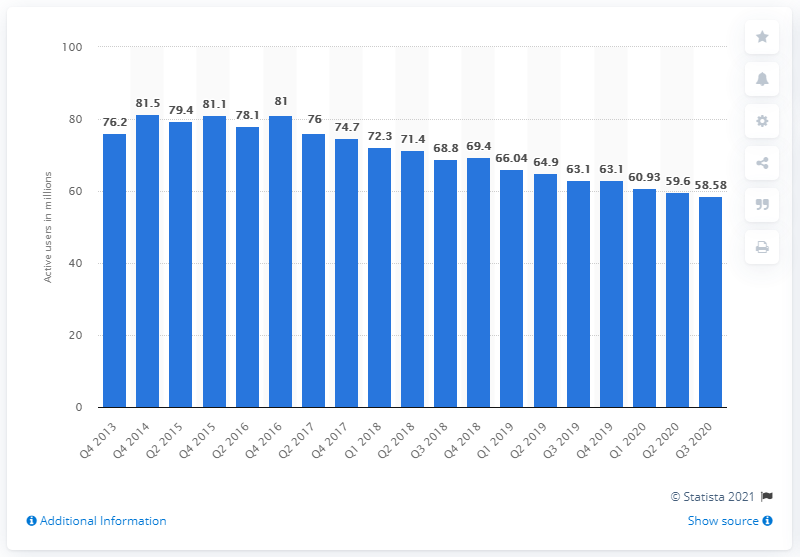Identify some key points in this picture. Pandora had 58,580 monthly active users in the US in the third quarter of 2020. Pandora has lost approximately 58.58% of its users in the last two years. 